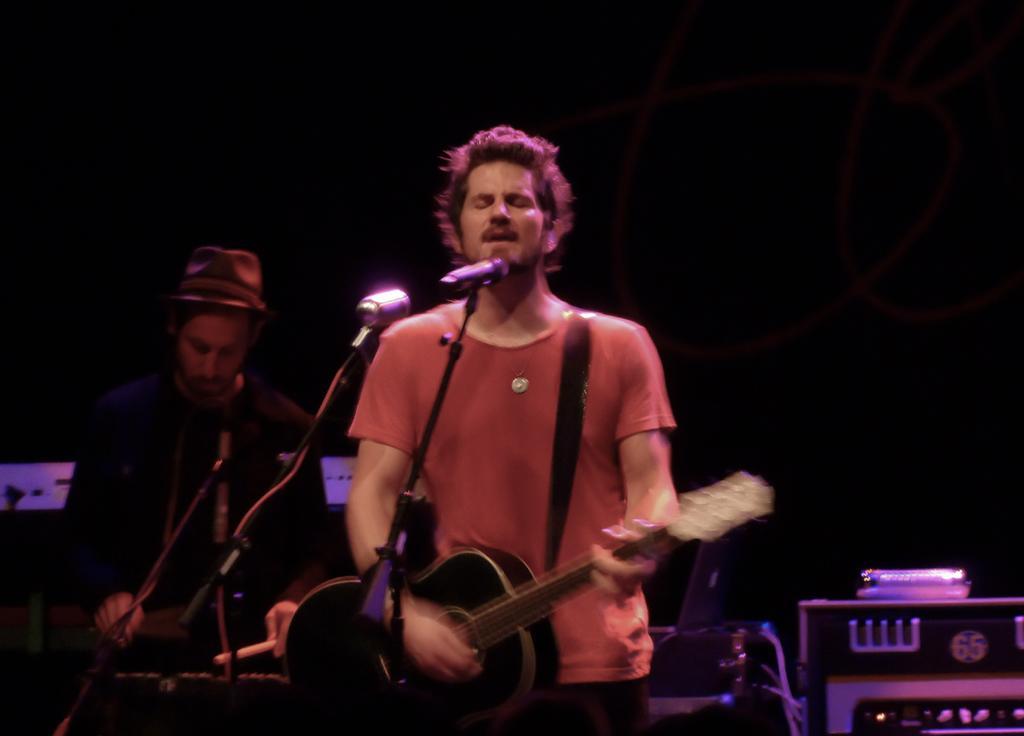Please provide a concise description of this image. Background is dark. Here we can see one man standing in front of a mike singing and playing guitar. Behind to him we can see other man wearing hat and playing drums. At the right side of the picture we can see a device. 